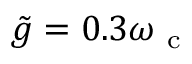Convert formula to latex. <formula><loc_0><loc_0><loc_500><loc_500>\tilde { g } = 0 . 3 \omega _ { c }</formula> 